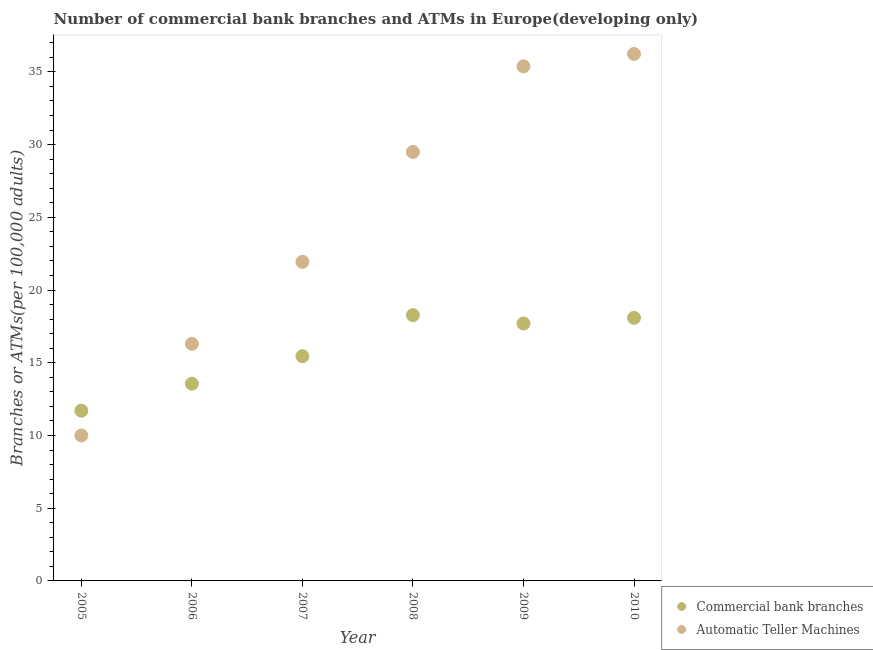How many different coloured dotlines are there?
Your answer should be compact. 2. What is the number of commercal bank branches in 2007?
Your answer should be compact. 15.45. Across all years, what is the maximum number of atms?
Make the answer very short. 36.23. Across all years, what is the minimum number of atms?
Ensure brevity in your answer.  10. In which year was the number of commercal bank branches maximum?
Your answer should be very brief. 2008. What is the total number of commercal bank branches in the graph?
Your answer should be very brief. 94.78. What is the difference between the number of commercal bank branches in 2006 and that in 2010?
Offer a terse response. -4.53. What is the difference between the number of commercal bank branches in 2006 and the number of atms in 2005?
Ensure brevity in your answer.  3.56. What is the average number of commercal bank branches per year?
Keep it short and to the point. 15.8. In the year 2007, what is the difference between the number of atms and number of commercal bank branches?
Provide a short and direct response. 6.49. In how many years, is the number of atms greater than 1?
Offer a terse response. 6. What is the ratio of the number of atms in 2006 to that in 2010?
Keep it short and to the point. 0.45. Is the difference between the number of atms in 2008 and 2010 greater than the difference between the number of commercal bank branches in 2008 and 2010?
Your answer should be very brief. No. What is the difference between the highest and the second highest number of atms?
Your response must be concise. 0.85. What is the difference between the highest and the lowest number of atms?
Your answer should be compact. 26.23. In how many years, is the number of atms greater than the average number of atms taken over all years?
Ensure brevity in your answer.  3. Is the number of atms strictly greater than the number of commercal bank branches over the years?
Provide a short and direct response. No. Is the number of atms strictly less than the number of commercal bank branches over the years?
Make the answer very short. No. What is the difference between two consecutive major ticks on the Y-axis?
Your answer should be compact. 5. Does the graph contain grids?
Your response must be concise. No. What is the title of the graph?
Provide a short and direct response. Number of commercial bank branches and ATMs in Europe(developing only). What is the label or title of the X-axis?
Provide a succinct answer. Year. What is the label or title of the Y-axis?
Your answer should be very brief. Branches or ATMs(per 100,0 adults). What is the Branches or ATMs(per 100,000 adults) in Commercial bank branches in 2005?
Ensure brevity in your answer.  11.71. What is the Branches or ATMs(per 100,000 adults) of Automatic Teller Machines in 2005?
Your answer should be very brief. 10. What is the Branches or ATMs(per 100,000 adults) in Commercial bank branches in 2006?
Give a very brief answer. 13.56. What is the Branches or ATMs(per 100,000 adults) of Automatic Teller Machines in 2006?
Provide a short and direct response. 16.3. What is the Branches or ATMs(per 100,000 adults) of Commercial bank branches in 2007?
Make the answer very short. 15.45. What is the Branches or ATMs(per 100,000 adults) in Automatic Teller Machines in 2007?
Keep it short and to the point. 21.94. What is the Branches or ATMs(per 100,000 adults) in Commercial bank branches in 2008?
Your response must be concise. 18.27. What is the Branches or ATMs(per 100,000 adults) in Automatic Teller Machines in 2008?
Your answer should be very brief. 29.5. What is the Branches or ATMs(per 100,000 adults) in Commercial bank branches in 2009?
Ensure brevity in your answer.  17.7. What is the Branches or ATMs(per 100,000 adults) in Automatic Teller Machines in 2009?
Keep it short and to the point. 35.38. What is the Branches or ATMs(per 100,000 adults) in Commercial bank branches in 2010?
Offer a terse response. 18.09. What is the Branches or ATMs(per 100,000 adults) of Automatic Teller Machines in 2010?
Provide a short and direct response. 36.23. Across all years, what is the maximum Branches or ATMs(per 100,000 adults) of Commercial bank branches?
Your answer should be compact. 18.27. Across all years, what is the maximum Branches or ATMs(per 100,000 adults) in Automatic Teller Machines?
Your answer should be very brief. 36.23. Across all years, what is the minimum Branches or ATMs(per 100,000 adults) in Commercial bank branches?
Provide a short and direct response. 11.71. Across all years, what is the minimum Branches or ATMs(per 100,000 adults) of Automatic Teller Machines?
Make the answer very short. 10. What is the total Branches or ATMs(per 100,000 adults) of Commercial bank branches in the graph?
Your answer should be very brief. 94.78. What is the total Branches or ATMs(per 100,000 adults) of Automatic Teller Machines in the graph?
Offer a terse response. 149.36. What is the difference between the Branches or ATMs(per 100,000 adults) in Commercial bank branches in 2005 and that in 2006?
Provide a succinct answer. -1.85. What is the difference between the Branches or ATMs(per 100,000 adults) in Automatic Teller Machines in 2005 and that in 2006?
Make the answer very short. -6.3. What is the difference between the Branches or ATMs(per 100,000 adults) in Commercial bank branches in 2005 and that in 2007?
Keep it short and to the point. -3.74. What is the difference between the Branches or ATMs(per 100,000 adults) in Automatic Teller Machines in 2005 and that in 2007?
Offer a terse response. -11.94. What is the difference between the Branches or ATMs(per 100,000 adults) in Commercial bank branches in 2005 and that in 2008?
Keep it short and to the point. -6.57. What is the difference between the Branches or ATMs(per 100,000 adults) in Automatic Teller Machines in 2005 and that in 2008?
Offer a very short reply. -19.49. What is the difference between the Branches or ATMs(per 100,000 adults) of Commercial bank branches in 2005 and that in 2009?
Offer a terse response. -6. What is the difference between the Branches or ATMs(per 100,000 adults) in Automatic Teller Machines in 2005 and that in 2009?
Provide a short and direct response. -25.38. What is the difference between the Branches or ATMs(per 100,000 adults) in Commercial bank branches in 2005 and that in 2010?
Keep it short and to the point. -6.38. What is the difference between the Branches or ATMs(per 100,000 adults) in Automatic Teller Machines in 2005 and that in 2010?
Offer a very short reply. -26.23. What is the difference between the Branches or ATMs(per 100,000 adults) in Commercial bank branches in 2006 and that in 2007?
Provide a short and direct response. -1.89. What is the difference between the Branches or ATMs(per 100,000 adults) of Automatic Teller Machines in 2006 and that in 2007?
Keep it short and to the point. -5.64. What is the difference between the Branches or ATMs(per 100,000 adults) of Commercial bank branches in 2006 and that in 2008?
Your answer should be very brief. -4.71. What is the difference between the Branches or ATMs(per 100,000 adults) of Automatic Teller Machines in 2006 and that in 2008?
Your answer should be compact. -13.19. What is the difference between the Branches or ATMs(per 100,000 adults) in Commercial bank branches in 2006 and that in 2009?
Provide a short and direct response. -4.14. What is the difference between the Branches or ATMs(per 100,000 adults) in Automatic Teller Machines in 2006 and that in 2009?
Your response must be concise. -19.08. What is the difference between the Branches or ATMs(per 100,000 adults) of Commercial bank branches in 2006 and that in 2010?
Offer a terse response. -4.53. What is the difference between the Branches or ATMs(per 100,000 adults) of Automatic Teller Machines in 2006 and that in 2010?
Offer a very short reply. -19.93. What is the difference between the Branches or ATMs(per 100,000 adults) of Commercial bank branches in 2007 and that in 2008?
Keep it short and to the point. -2.82. What is the difference between the Branches or ATMs(per 100,000 adults) of Automatic Teller Machines in 2007 and that in 2008?
Provide a succinct answer. -7.55. What is the difference between the Branches or ATMs(per 100,000 adults) of Commercial bank branches in 2007 and that in 2009?
Offer a terse response. -2.25. What is the difference between the Branches or ATMs(per 100,000 adults) in Automatic Teller Machines in 2007 and that in 2009?
Offer a terse response. -13.44. What is the difference between the Branches or ATMs(per 100,000 adults) of Commercial bank branches in 2007 and that in 2010?
Your response must be concise. -2.64. What is the difference between the Branches or ATMs(per 100,000 adults) in Automatic Teller Machines in 2007 and that in 2010?
Provide a succinct answer. -14.29. What is the difference between the Branches or ATMs(per 100,000 adults) in Commercial bank branches in 2008 and that in 2009?
Your answer should be very brief. 0.57. What is the difference between the Branches or ATMs(per 100,000 adults) in Automatic Teller Machines in 2008 and that in 2009?
Your response must be concise. -5.88. What is the difference between the Branches or ATMs(per 100,000 adults) in Commercial bank branches in 2008 and that in 2010?
Offer a terse response. 0.18. What is the difference between the Branches or ATMs(per 100,000 adults) of Automatic Teller Machines in 2008 and that in 2010?
Keep it short and to the point. -6.74. What is the difference between the Branches or ATMs(per 100,000 adults) in Commercial bank branches in 2009 and that in 2010?
Make the answer very short. -0.39. What is the difference between the Branches or ATMs(per 100,000 adults) in Automatic Teller Machines in 2009 and that in 2010?
Offer a very short reply. -0.85. What is the difference between the Branches or ATMs(per 100,000 adults) of Commercial bank branches in 2005 and the Branches or ATMs(per 100,000 adults) of Automatic Teller Machines in 2006?
Your answer should be very brief. -4.6. What is the difference between the Branches or ATMs(per 100,000 adults) in Commercial bank branches in 2005 and the Branches or ATMs(per 100,000 adults) in Automatic Teller Machines in 2007?
Keep it short and to the point. -10.24. What is the difference between the Branches or ATMs(per 100,000 adults) in Commercial bank branches in 2005 and the Branches or ATMs(per 100,000 adults) in Automatic Teller Machines in 2008?
Ensure brevity in your answer.  -17.79. What is the difference between the Branches or ATMs(per 100,000 adults) in Commercial bank branches in 2005 and the Branches or ATMs(per 100,000 adults) in Automatic Teller Machines in 2009?
Provide a short and direct response. -23.68. What is the difference between the Branches or ATMs(per 100,000 adults) in Commercial bank branches in 2005 and the Branches or ATMs(per 100,000 adults) in Automatic Teller Machines in 2010?
Offer a very short reply. -24.53. What is the difference between the Branches or ATMs(per 100,000 adults) in Commercial bank branches in 2006 and the Branches or ATMs(per 100,000 adults) in Automatic Teller Machines in 2007?
Keep it short and to the point. -8.38. What is the difference between the Branches or ATMs(per 100,000 adults) of Commercial bank branches in 2006 and the Branches or ATMs(per 100,000 adults) of Automatic Teller Machines in 2008?
Make the answer very short. -15.94. What is the difference between the Branches or ATMs(per 100,000 adults) of Commercial bank branches in 2006 and the Branches or ATMs(per 100,000 adults) of Automatic Teller Machines in 2009?
Offer a terse response. -21.82. What is the difference between the Branches or ATMs(per 100,000 adults) of Commercial bank branches in 2006 and the Branches or ATMs(per 100,000 adults) of Automatic Teller Machines in 2010?
Provide a short and direct response. -22.67. What is the difference between the Branches or ATMs(per 100,000 adults) of Commercial bank branches in 2007 and the Branches or ATMs(per 100,000 adults) of Automatic Teller Machines in 2008?
Provide a short and direct response. -14.05. What is the difference between the Branches or ATMs(per 100,000 adults) in Commercial bank branches in 2007 and the Branches or ATMs(per 100,000 adults) in Automatic Teller Machines in 2009?
Your response must be concise. -19.93. What is the difference between the Branches or ATMs(per 100,000 adults) in Commercial bank branches in 2007 and the Branches or ATMs(per 100,000 adults) in Automatic Teller Machines in 2010?
Provide a succinct answer. -20.78. What is the difference between the Branches or ATMs(per 100,000 adults) in Commercial bank branches in 2008 and the Branches or ATMs(per 100,000 adults) in Automatic Teller Machines in 2009?
Ensure brevity in your answer.  -17.11. What is the difference between the Branches or ATMs(per 100,000 adults) in Commercial bank branches in 2008 and the Branches or ATMs(per 100,000 adults) in Automatic Teller Machines in 2010?
Offer a terse response. -17.96. What is the difference between the Branches or ATMs(per 100,000 adults) in Commercial bank branches in 2009 and the Branches or ATMs(per 100,000 adults) in Automatic Teller Machines in 2010?
Provide a short and direct response. -18.53. What is the average Branches or ATMs(per 100,000 adults) in Commercial bank branches per year?
Your response must be concise. 15.8. What is the average Branches or ATMs(per 100,000 adults) of Automatic Teller Machines per year?
Give a very brief answer. 24.89. In the year 2005, what is the difference between the Branches or ATMs(per 100,000 adults) in Commercial bank branches and Branches or ATMs(per 100,000 adults) in Automatic Teller Machines?
Give a very brief answer. 1.7. In the year 2006, what is the difference between the Branches or ATMs(per 100,000 adults) in Commercial bank branches and Branches or ATMs(per 100,000 adults) in Automatic Teller Machines?
Your answer should be very brief. -2.74. In the year 2007, what is the difference between the Branches or ATMs(per 100,000 adults) of Commercial bank branches and Branches or ATMs(per 100,000 adults) of Automatic Teller Machines?
Make the answer very short. -6.49. In the year 2008, what is the difference between the Branches or ATMs(per 100,000 adults) in Commercial bank branches and Branches or ATMs(per 100,000 adults) in Automatic Teller Machines?
Offer a very short reply. -11.22. In the year 2009, what is the difference between the Branches or ATMs(per 100,000 adults) in Commercial bank branches and Branches or ATMs(per 100,000 adults) in Automatic Teller Machines?
Provide a succinct answer. -17.68. In the year 2010, what is the difference between the Branches or ATMs(per 100,000 adults) of Commercial bank branches and Branches or ATMs(per 100,000 adults) of Automatic Teller Machines?
Provide a succinct answer. -18.14. What is the ratio of the Branches or ATMs(per 100,000 adults) in Commercial bank branches in 2005 to that in 2006?
Provide a short and direct response. 0.86. What is the ratio of the Branches or ATMs(per 100,000 adults) of Automatic Teller Machines in 2005 to that in 2006?
Offer a terse response. 0.61. What is the ratio of the Branches or ATMs(per 100,000 adults) of Commercial bank branches in 2005 to that in 2007?
Your response must be concise. 0.76. What is the ratio of the Branches or ATMs(per 100,000 adults) of Automatic Teller Machines in 2005 to that in 2007?
Your answer should be compact. 0.46. What is the ratio of the Branches or ATMs(per 100,000 adults) of Commercial bank branches in 2005 to that in 2008?
Provide a short and direct response. 0.64. What is the ratio of the Branches or ATMs(per 100,000 adults) of Automatic Teller Machines in 2005 to that in 2008?
Provide a short and direct response. 0.34. What is the ratio of the Branches or ATMs(per 100,000 adults) in Commercial bank branches in 2005 to that in 2009?
Make the answer very short. 0.66. What is the ratio of the Branches or ATMs(per 100,000 adults) of Automatic Teller Machines in 2005 to that in 2009?
Make the answer very short. 0.28. What is the ratio of the Branches or ATMs(per 100,000 adults) in Commercial bank branches in 2005 to that in 2010?
Offer a very short reply. 0.65. What is the ratio of the Branches or ATMs(per 100,000 adults) of Automatic Teller Machines in 2005 to that in 2010?
Offer a very short reply. 0.28. What is the ratio of the Branches or ATMs(per 100,000 adults) of Commercial bank branches in 2006 to that in 2007?
Your answer should be very brief. 0.88. What is the ratio of the Branches or ATMs(per 100,000 adults) of Automatic Teller Machines in 2006 to that in 2007?
Ensure brevity in your answer.  0.74. What is the ratio of the Branches or ATMs(per 100,000 adults) in Commercial bank branches in 2006 to that in 2008?
Offer a very short reply. 0.74. What is the ratio of the Branches or ATMs(per 100,000 adults) of Automatic Teller Machines in 2006 to that in 2008?
Ensure brevity in your answer.  0.55. What is the ratio of the Branches or ATMs(per 100,000 adults) of Commercial bank branches in 2006 to that in 2009?
Provide a short and direct response. 0.77. What is the ratio of the Branches or ATMs(per 100,000 adults) of Automatic Teller Machines in 2006 to that in 2009?
Ensure brevity in your answer.  0.46. What is the ratio of the Branches or ATMs(per 100,000 adults) of Commercial bank branches in 2006 to that in 2010?
Your answer should be compact. 0.75. What is the ratio of the Branches or ATMs(per 100,000 adults) of Automatic Teller Machines in 2006 to that in 2010?
Make the answer very short. 0.45. What is the ratio of the Branches or ATMs(per 100,000 adults) of Commercial bank branches in 2007 to that in 2008?
Make the answer very short. 0.85. What is the ratio of the Branches or ATMs(per 100,000 adults) in Automatic Teller Machines in 2007 to that in 2008?
Your response must be concise. 0.74. What is the ratio of the Branches or ATMs(per 100,000 adults) in Commercial bank branches in 2007 to that in 2009?
Offer a terse response. 0.87. What is the ratio of the Branches or ATMs(per 100,000 adults) in Automatic Teller Machines in 2007 to that in 2009?
Give a very brief answer. 0.62. What is the ratio of the Branches or ATMs(per 100,000 adults) in Commercial bank branches in 2007 to that in 2010?
Ensure brevity in your answer.  0.85. What is the ratio of the Branches or ATMs(per 100,000 adults) of Automatic Teller Machines in 2007 to that in 2010?
Make the answer very short. 0.61. What is the ratio of the Branches or ATMs(per 100,000 adults) of Commercial bank branches in 2008 to that in 2009?
Ensure brevity in your answer.  1.03. What is the ratio of the Branches or ATMs(per 100,000 adults) in Automatic Teller Machines in 2008 to that in 2009?
Your answer should be very brief. 0.83. What is the ratio of the Branches or ATMs(per 100,000 adults) in Commercial bank branches in 2008 to that in 2010?
Provide a succinct answer. 1.01. What is the ratio of the Branches or ATMs(per 100,000 adults) in Automatic Teller Machines in 2008 to that in 2010?
Provide a succinct answer. 0.81. What is the ratio of the Branches or ATMs(per 100,000 adults) of Commercial bank branches in 2009 to that in 2010?
Provide a short and direct response. 0.98. What is the ratio of the Branches or ATMs(per 100,000 adults) in Automatic Teller Machines in 2009 to that in 2010?
Your answer should be compact. 0.98. What is the difference between the highest and the second highest Branches or ATMs(per 100,000 adults) in Commercial bank branches?
Your response must be concise. 0.18. What is the difference between the highest and the second highest Branches or ATMs(per 100,000 adults) in Automatic Teller Machines?
Make the answer very short. 0.85. What is the difference between the highest and the lowest Branches or ATMs(per 100,000 adults) in Commercial bank branches?
Give a very brief answer. 6.57. What is the difference between the highest and the lowest Branches or ATMs(per 100,000 adults) in Automatic Teller Machines?
Make the answer very short. 26.23. 